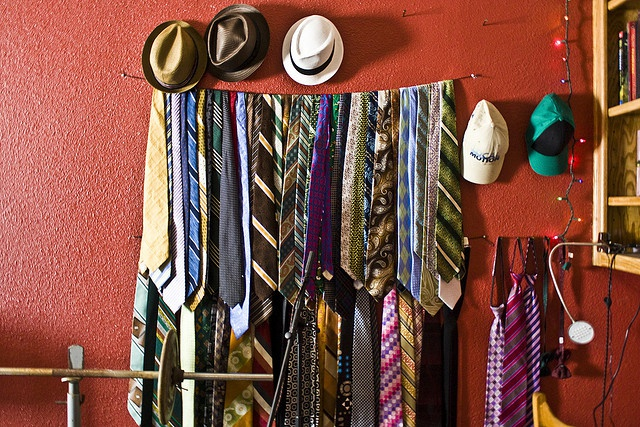Describe the objects in this image and their specific colors. I can see tie in red, black, white, gray, and maroon tones, tie in red, black, maroon, and gray tones, tie in red, black, and olive tones, tie in red, black, maroon, and white tones, and tie in red, khaki, beige, tan, and black tones in this image. 